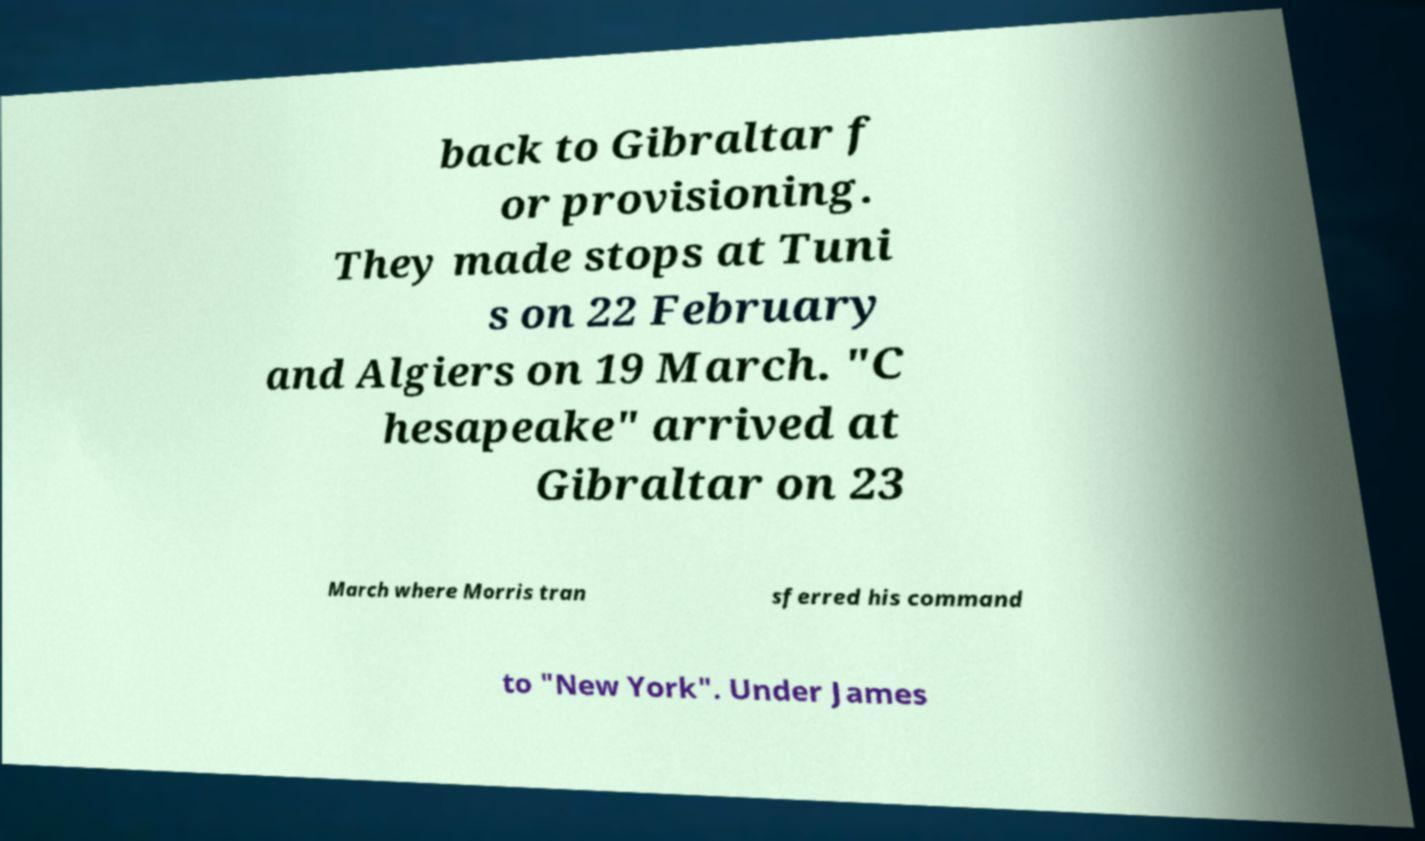Can you accurately transcribe the text from the provided image for me? back to Gibraltar f or provisioning. They made stops at Tuni s on 22 February and Algiers on 19 March. "C hesapeake" arrived at Gibraltar on 23 March where Morris tran sferred his command to "New York". Under James 